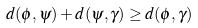<formula> <loc_0><loc_0><loc_500><loc_500>d ( \phi , \psi ) + d ( \psi , \gamma ) \geq d ( \phi , \gamma )</formula> 